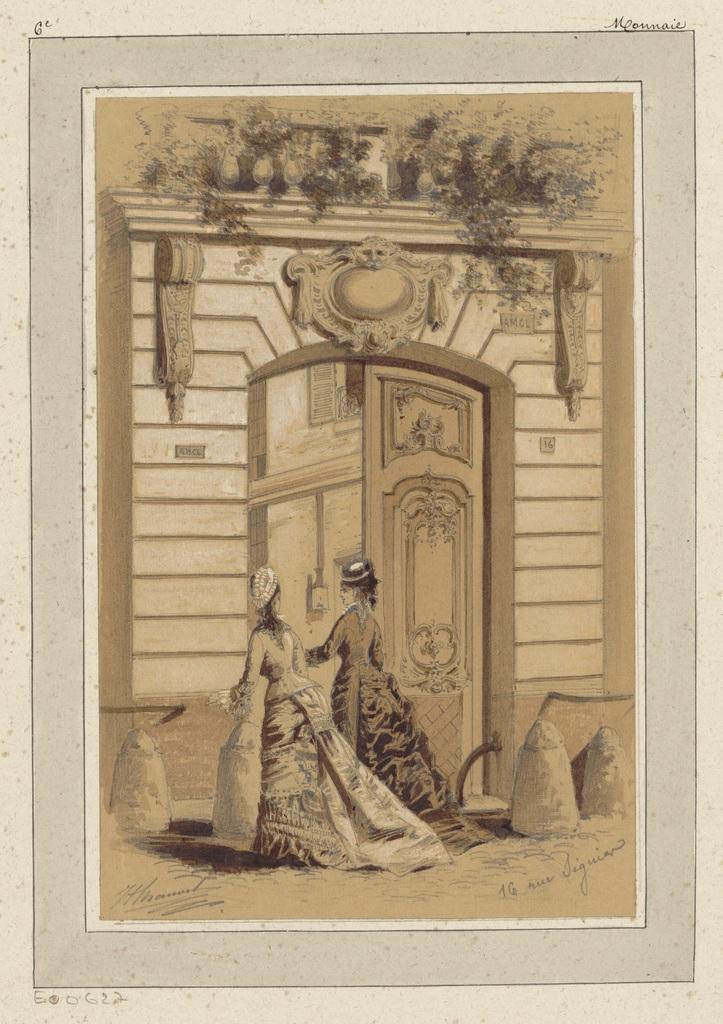What is depicted in the painting in the image? The painting contains a building. Are there any people or animals in the painting? No, there are no animals in the painting, but there are two women walking in front of the building. What can be found at the bottom of the painting? There is some text at the bottom of the painting. Can you see any pigs playing volleyball in the amusement park in the image? There is no amusement park, pigs, or volleyball present in the image. 